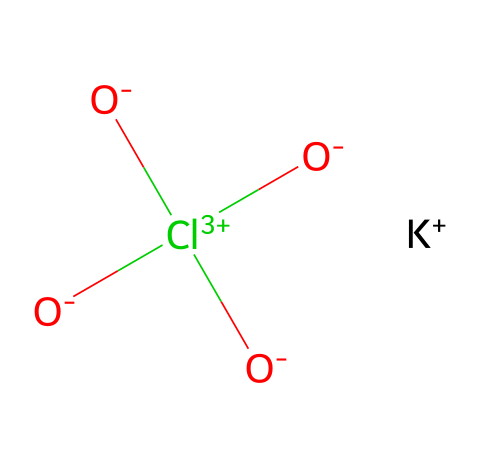How many oxygen atoms are in potassium perchlorate? By examining the structure represented by the SMILES, we can identify that the compound contains four oxygen atoms indicated by the 'O' symbols that are bonded to the chlorine atom.
Answer: four What is the central atom in potassium perchlorate? The chlorine atom is depicted in the center of the structure as it is connected to the multiple oxygen atoms through double bonds. Therefore, it serves as the central atom of the compound.
Answer: chlorine How many total bonds are formed by the chlorine atom? In the chemical structure, the chlorine atom forms four bonds: three double bonds with three oxygen atoms and one single bond with the negative oxygen atom. Thus, the total number of bonds is four.
Answer: four What is the charge of potassium in this compound? The potassium atom in potassium perchlorate is shown as 'K+' which indicates that it has a single positive charge.
Answer: one positive Why is potassium perchlorate classified as a non-electrolyte? Potassium perchlorate does not dissociate into ions in solutions like electrolytes do, therefore it behaves as a non-electrolyte. Its structure supports this classification as it features ionic interactions rather than a complete ionic dissolution in water.
Answer: does not dissociate What type of chemical bonds are present between the chlorine and oxygen atoms? The bonds between the chlorine and oxygen atoms in potassium perchlorate are primarily double bonds. This can be determined from the structure indicated in the SMILES, where '=' signifies the presence of double bonds.
Answer: double bonds What role does potassium perchlorate play in fireworks? Potassium perchlorate serves as an oxidizer in fireworks, enabling the combustion of fuel components and thereby facilitating the production of bursts of color and sound. This role is inferred from its reactive properties as an oxidizing agent due to the presence of oxygen in its structure.
Answer: oxidizer 